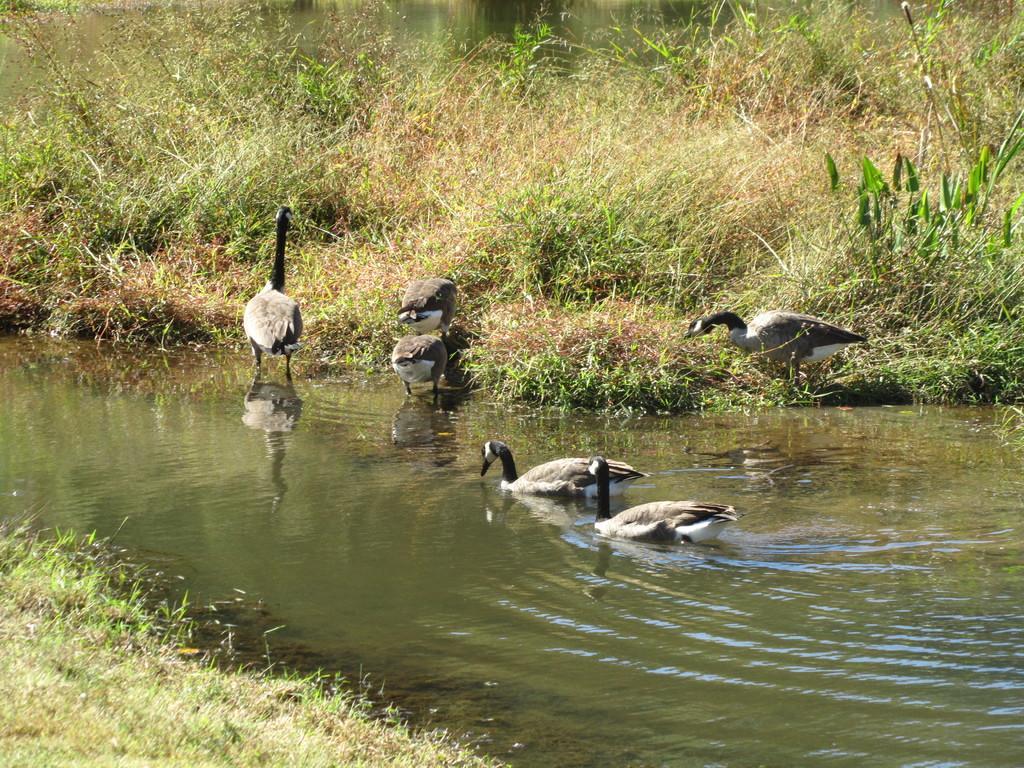How would you summarize this image in a sentence or two? In this image, we can see few birds and water. Top of the image, we can see plants. On the left side bottom corner, we can see grass. Here we can see few birds are in the water. 